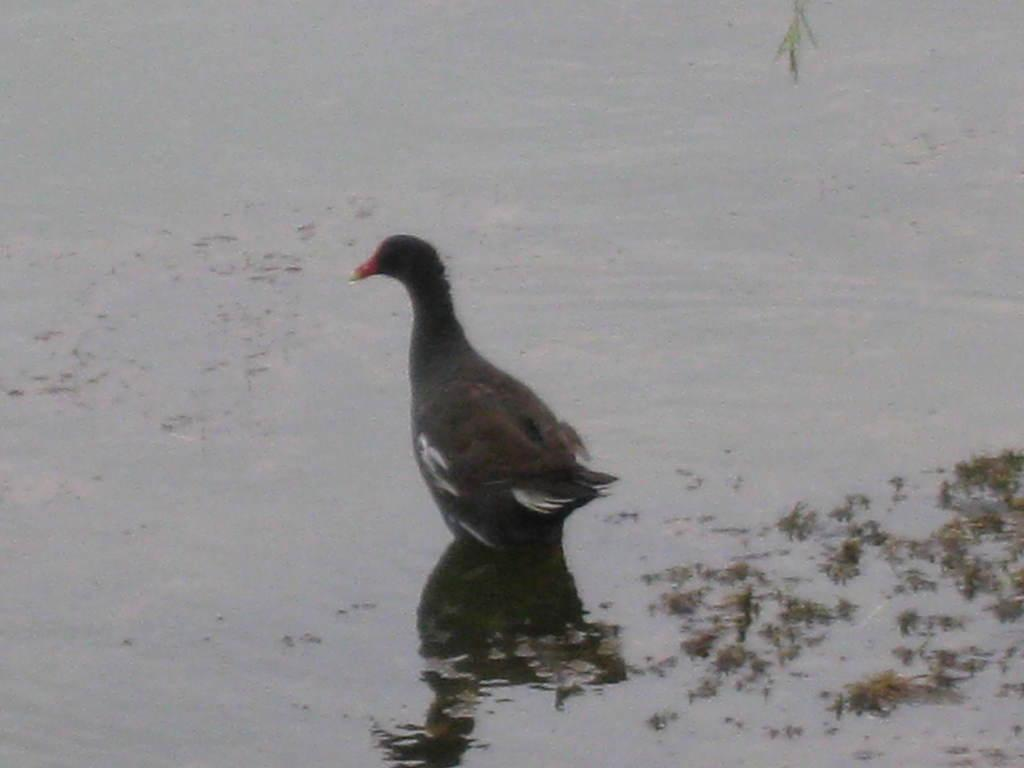What type of animal is on the surface of the water in the image? There is a bird on the surface of the water in the image. What type of vegetation can be seen on the right side of the image? There is grass visible on the right side of the image. What religion does the bird on the water practice in the image? There is no information about the bird's religion in the image. How does the bird on the water maintain its grip on the water's surface? The image does not provide information about how the bird maintains its grip on the water's surface. 